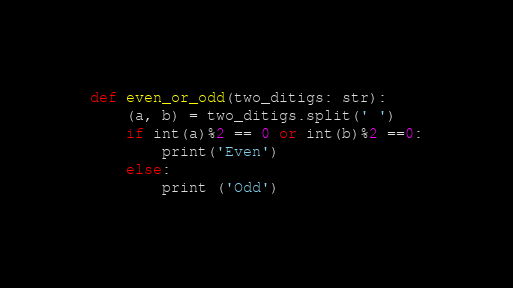Convert code to text. <code><loc_0><loc_0><loc_500><loc_500><_Python_>def even_or_odd(two_ditigs: str):
    (a, b) = two_ditigs.split(' ')
    if int(a)%2 == 0 or int(b)%2 ==0:
        print('Even')
    else:
        print ('Odd')</code> 